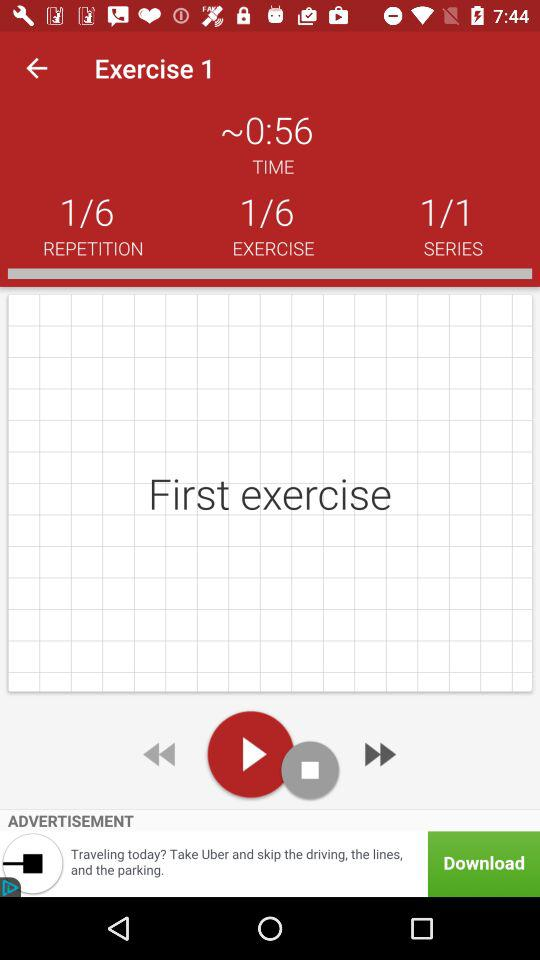How many more repetitions are there than series?
Answer the question using a single word or phrase. 5 